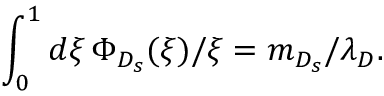<formula> <loc_0><loc_0><loc_500><loc_500>\int _ { 0 } ^ { 1 } d \xi \, \Phi _ { D _ { s } } ( \xi ) / \xi = m _ { D _ { s } } / \lambda _ { D } .</formula> 